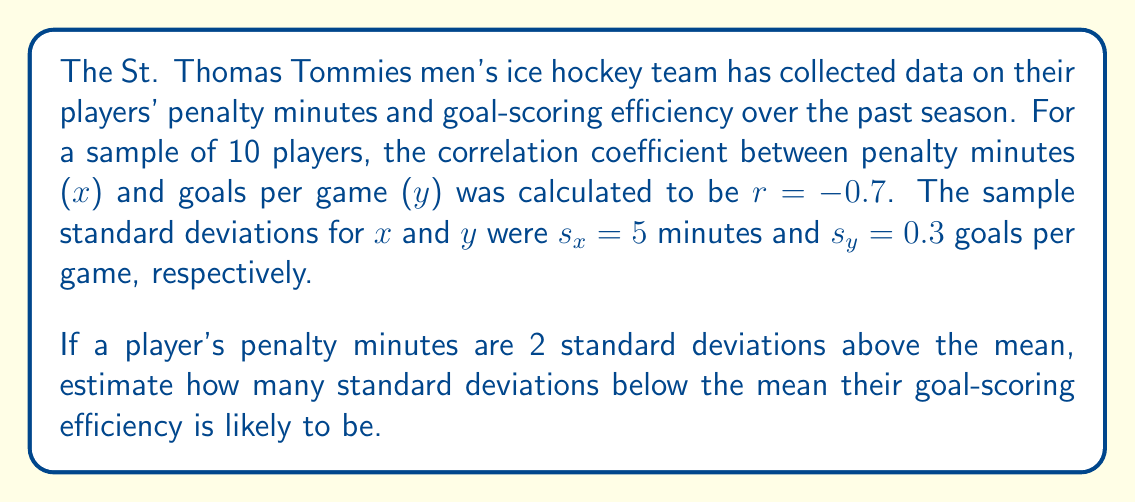Solve this math problem. To solve this problem, we'll use the properties of correlation and linear regression. The key concept here is the interpretation of the correlation coefficient in terms of standard deviations.

1) The correlation coefficient r = -0.7 indicates a strong negative linear relationship between penalty minutes and goal-scoring efficiency.

2) In a linear relationship, we can use the formula:

   $$\frac{y - \mu_y}{\sigma_y} = r \cdot \frac{x - \mu_x}{\sigma_x}$$

   Where $\mu_x$ and $\mu_y$ are the means, and $\sigma_x$ and $\sigma_y$ are the standard deviations of x and y respectively.

3) We're told that the player's penalty minutes are 2 standard deviations above the mean, so:

   $$\frac{x - \mu_x}{\sigma_x} = 2$$

4) Substituting this and the given correlation coefficient into our formula:

   $$\frac{y - \mu_y}{\sigma_y} = -0.7 \cdot 2$$

5) Simplifying:

   $$\frac{y - \mu_y}{\sigma_y} = -1.4$$

This result indicates that the player's goal-scoring efficiency is likely to be 1.4 standard deviations below the mean.
Answer: 1.4 standard deviations below the mean 